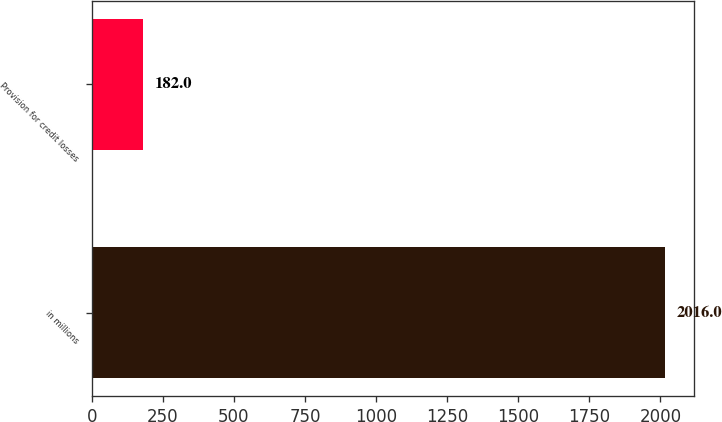<chart> <loc_0><loc_0><loc_500><loc_500><bar_chart><fcel>in millions<fcel>Provision for credit losses<nl><fcel>2016<fcel>182<nl></chart> 